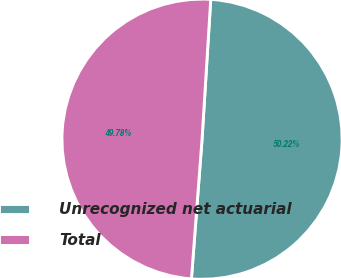Convert chart to OTSL. <chart><loc_0><loc_0><loc_500><loc_500><pie_chart><fcel>Unrecognized net actuarial<fcel>Total<nl><fcel>50.22%<fcel>49.78%<nl></chart> 